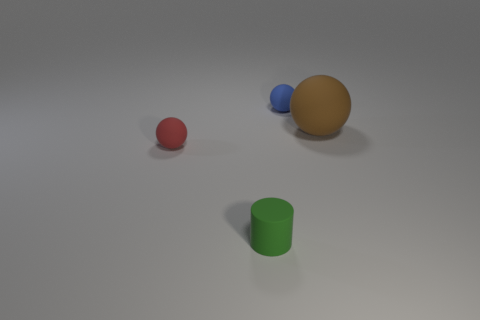Add 2 green matte objects. How many objects exist? 6 Subtract all balls. How many objects are left? 1 Add 3 blue matte spheres. How many blue matte spheres are left? 4 Add 1 small matte objects. How many small matte objects exist? 4 Subtract 0 purple spheres. How many objects are left? 4 Subtract all big purple metal balls. Subtract all tiny red objects. How many objects are left? 3 